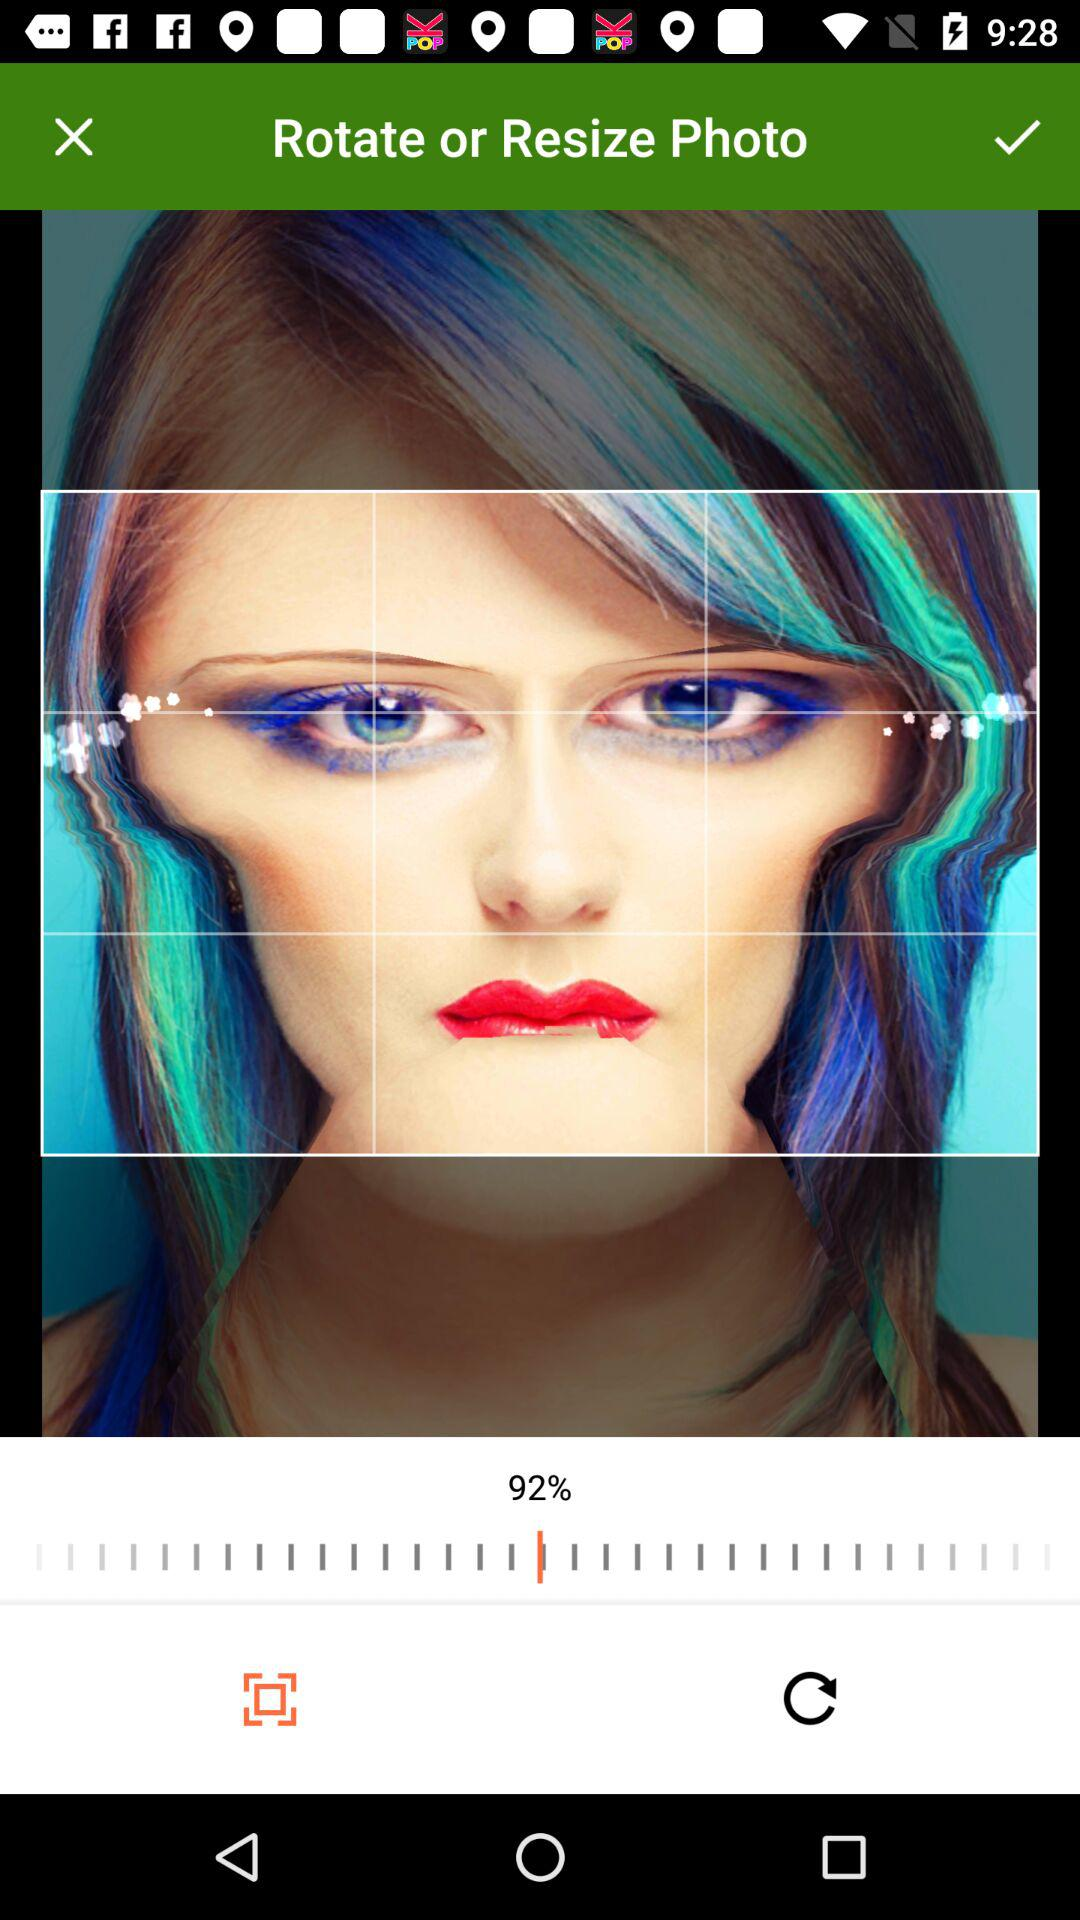How much is the resolution?
When the provided information is insufficient, respond with <no answer>. <no answer> 